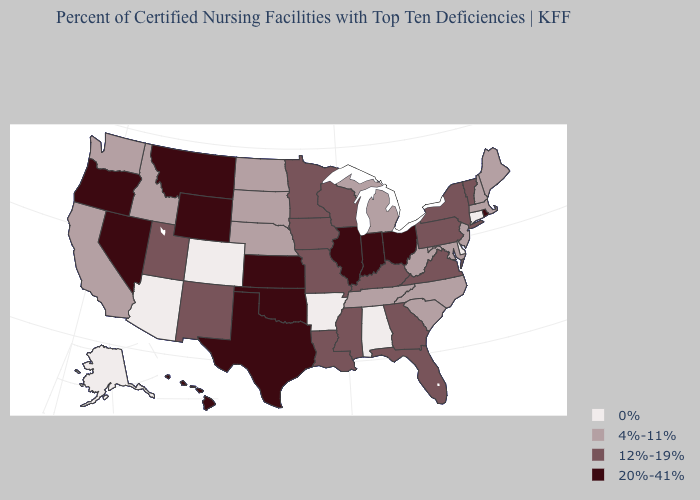Name the states that have a value in the range 4%-11%?
Be succinct. California, Idaho, Maine, Maryland, Massachusetts, Michigan, Nebraska, New Hampshire, New Jersey, North Carolina, North Dakota, South Carolina, South Dakota, Tennessee, Washington, West Virginia. Which states hav the highest value in the MidWest?
Quick response, please. Illinois, Indiana, Kansas, Ohio. Name the states that have a value in the range 12%-19%?
Be succinct. Florida, Georgia, Iowa, Kentucky, Louisiana, Minnesota, Mississippi, Missouri, New Mexico, New York, Pennsylvania, Utah, Vermont, Virginia, Wisconsin. What is the value of Wyoming?
Short answer required. 20%-41%. Does Washington have a higher value than Arkansas?
Keep it brief. Yes. Name the states that have a value in the range 20%-41%?
Keep it brief. Hawaii, Illinois, Indiana, Kansas, Montana, Nevada, Ohio, Oklahoma, Oregon, Rhode Island, Texas, Wyoming. Name the states that have a value in the range 0%?
Short answer required. Alabama, Alaska, Arizona, Arkansas, Colorado, Connecticut, Delaware. What is the value of Iowa?
Concise answer only. 12%-19%. Name the states that have a value in the range 12%-19%?
Concise answer only. Florida, Georgia, Iowa, Kentucky, Louisiana, Minnesota, Mississippi, Missouri, New Mexico, New York, Pennsylvania, Utah, Vermont, Virginia, Wisconsin. Does the map have missing data?
Concise answer only. No. What is the highest value in the USA?
Write a very short answer. 20%-41%. What is the value of Alabama?
Write a very short answer. 0%. What is the highest value in the Northeast ?
Quick response, please. 20%-41%. Name the states that have a value in the range 12%-19%?
Concise answer only. Florida, Georgia, Iowa, Kentucky, Louisiana, Minnesota, Mississippi, Missouri, New Mexico, New York, Pennsylvania, Utah, Vermont, Virginia, Wisconsin. Name the states that have a value in the range 12%-19%?
Concise answer only. Florida, Georgia, Iowa, Kentucky, Louisiana, Minnesota, Mississippi, Missouri, New Mexico, New York, Pennsylvania, Utah, Vermont, Virginia, Wisconsin. 